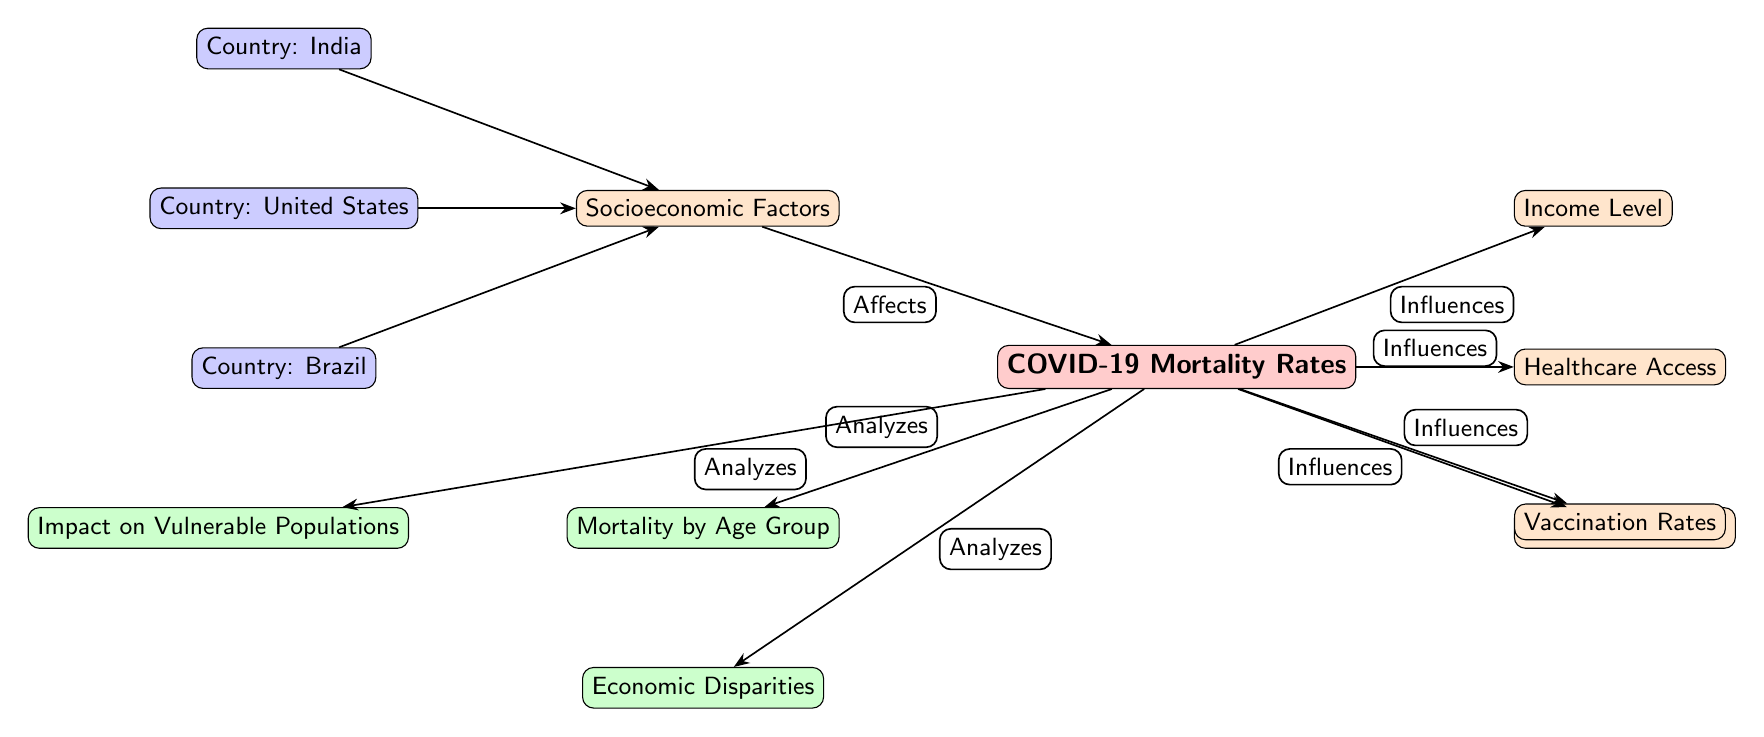What are the three countries mentioned in the diagram? The diagram provides three specific countries listed under the node labeled "Country." They are positioned next to each other in the visual representation.
Answer: United States, India, Brazil How many socioeconomic factors are influencing the COVID-19 mortality rates? The diagram lists four factors that impact COVID-19 mortality rates, located on the right side of the main node, indicating their influence.
Answer: 4 What is the relationship between socioeconomic factors and COVID-19 mortality rates? The diagram illustrates that socioeconomic factors "Affect" COVID-19 mortality rates, as indicated by the directional edge labeled "Affects" connecting the two nodes.
Answer: Affects Which socioeconomic factor has a direct connection to healthcare in the diagram? The diagram shows a direct edge originating from the main node of mortality rates, which connects to the healthcare access factor on the right side.
Answer: Healthcare Access What analyses are performed regarding COVID-19 mortality rates? The diagram details three impact analyses connected to the main mortality rates node, indicating the various factors analyzed. These analyses are shown with edges labeled "Analyzes."
Answer: Mortality by Age Group, Impact on Vulnerable Populations, Economic Disparities Which node directly influences the vaccination rates in the context of mortality? From the diagram, it is evident that the main node of COVID-19 mortality rates has a connection to vaccination rates, indicating its role in influencing that factor.
Answer: Influences How are income levels positioned in relation to COVID-19 mortality rates? The diagram shows that income levels are one of the factors that directly influence the main node of COVID-19 mortality rates and are placed on the right side.
Answer: Influences What type of analysis is related to the vulnerable populations in the context of COVID-19? The diagram indicates that "Impact on Vulnerable Populations" is a type of analysis directly connected to the main COVID-19 mortality rates node, thus showing its relationship in the context of the study.
Answer: Analyzes 